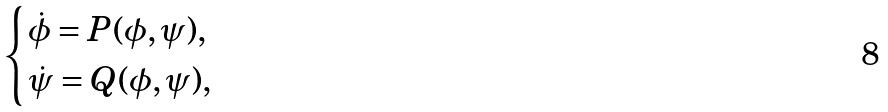Convert formula to latex. <formula><loc_0><loc_0><loc_500><loc_500>\begin{cases} \dot { \phi } = P ( \phi , \psi ) , \\ \dot { \psi } = Q ( \phi , \psi ) , \end{cases}</formula> 